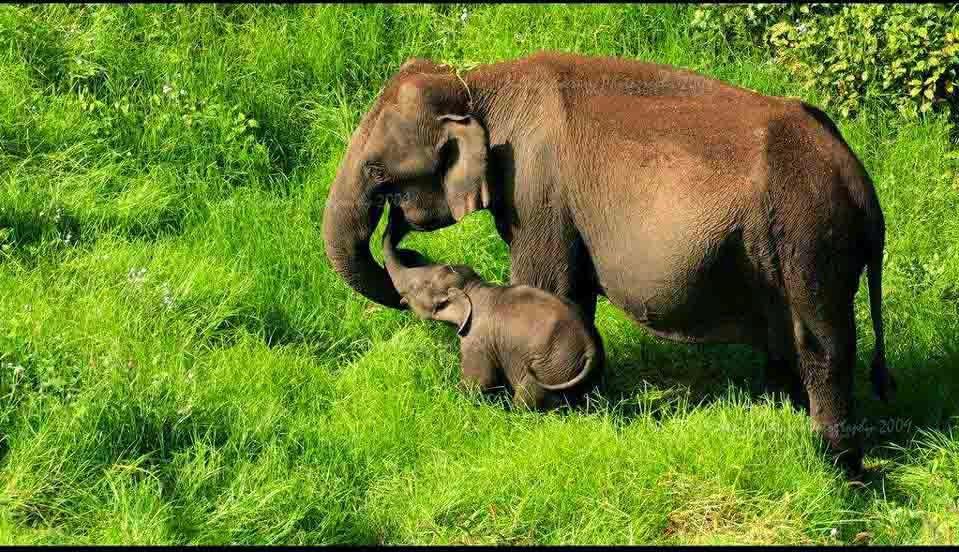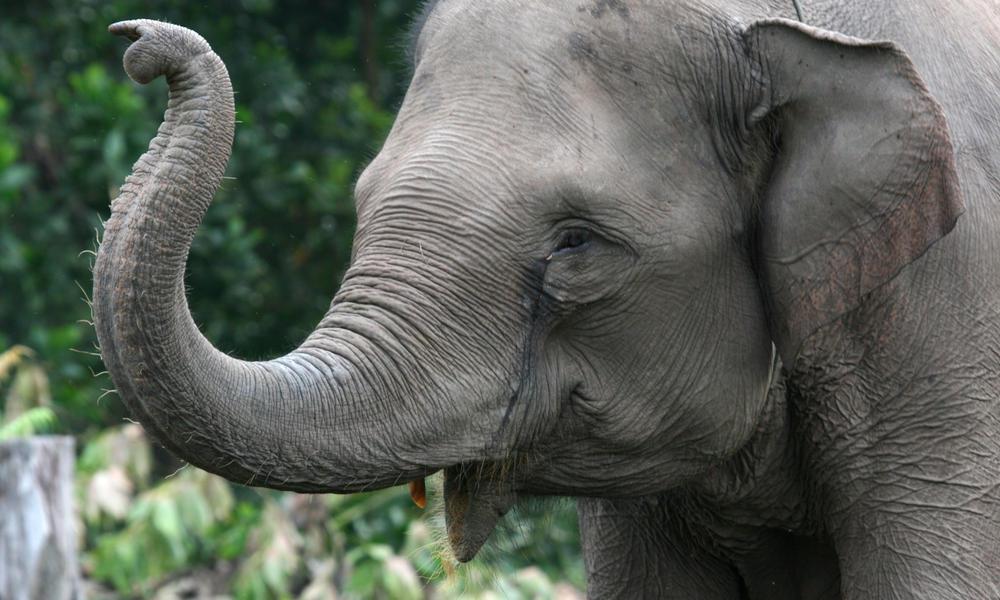The first image is the image on the left, the second image is the image on the right. For the images displayed, is the sentence "There are two elephants" factually correct? Answer yes or no. No. 